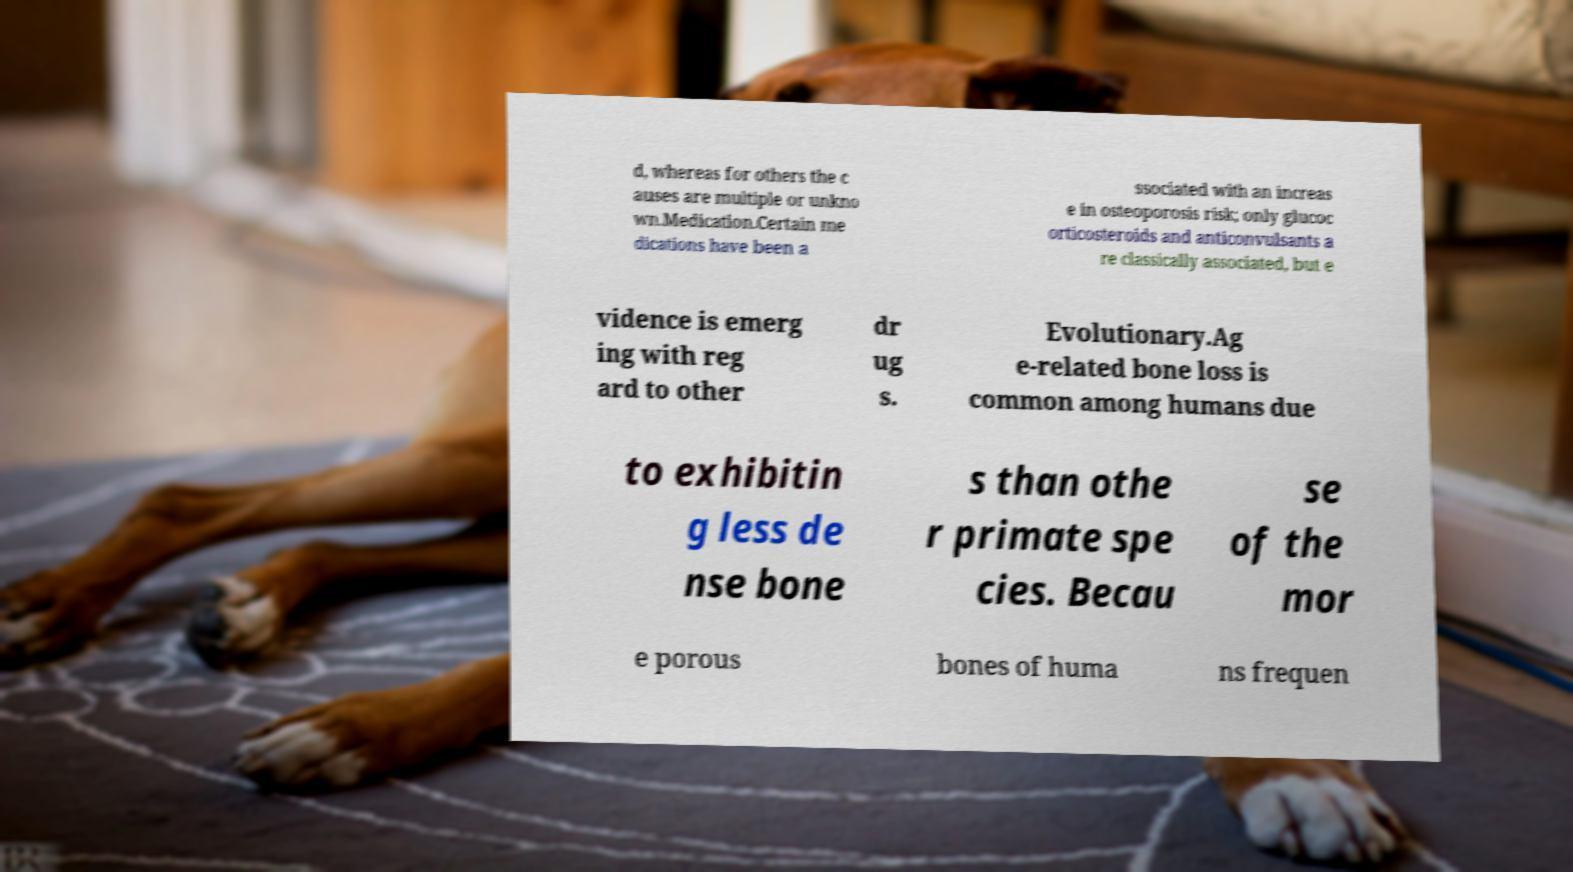I need the written content from this picture converted into text. Can you do that? d, whereas for others the c auses are multiple or unkno wn.Medication.Certain me dications have been a ssociated with an increas e in osteoporosis risk; only glucoc orticosteroids and anticonvulsants a re classically associated, but e vidence is emerg ing with reg ard to other dr ug s. Evolutionary.Ag e-related bone loss is common among humans due to exhibitin g less de nse bone s than othe r primate spe cies. Becau se of the mor e porous bones of huma ns frequen 